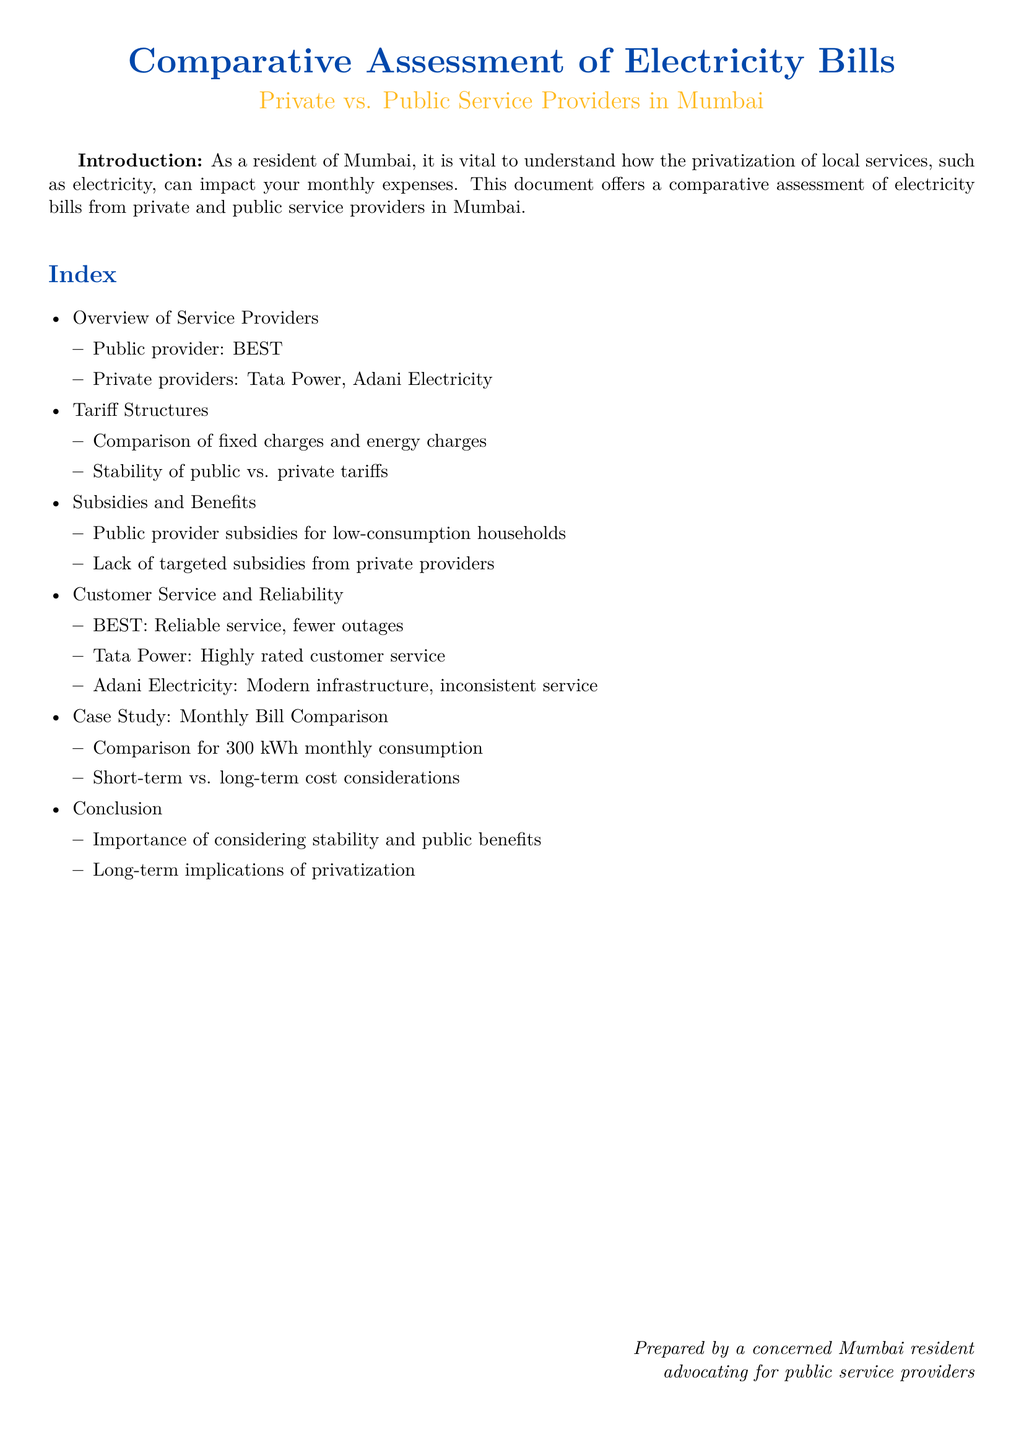what is the public provider mentioned in the document? The public provider mentioned in the document is BEST.
Answer: BEST how many private providers are listed? The document lists two private providers: Tata Power and Adani Electricity.
Answer: 2 which private provider has highly rated customer service? The document states that Tata Power has highly rated customer service.
Answer: Tata Power what is compared in the case study section? The case study section compares the monthly bill for 300 kWh monthly consumption.
Answer: 300 kWh what type of subsidies does the public provider offer? The public provider offers subsidies for low-consumption households.
Answer: Low-consumption households which private provider is noted for inconsistent service? Adani Electricity is noted for inconsistent service in the document.
Answer: Adani Electricity what is the importance mentioned in the conclusion? The conclusion emphasizes the importance of considering stability and public benefits.
Answer: Stability and public benefits how is BEST described in terms of service reliability? BEST is described as having reliable service with fewer outages.
Answer: Reliable service what are the two aspects compared in tariff structures? The tariff structures compare fixed charges and energy charges.
Answer: Fixed charges and energy charges 